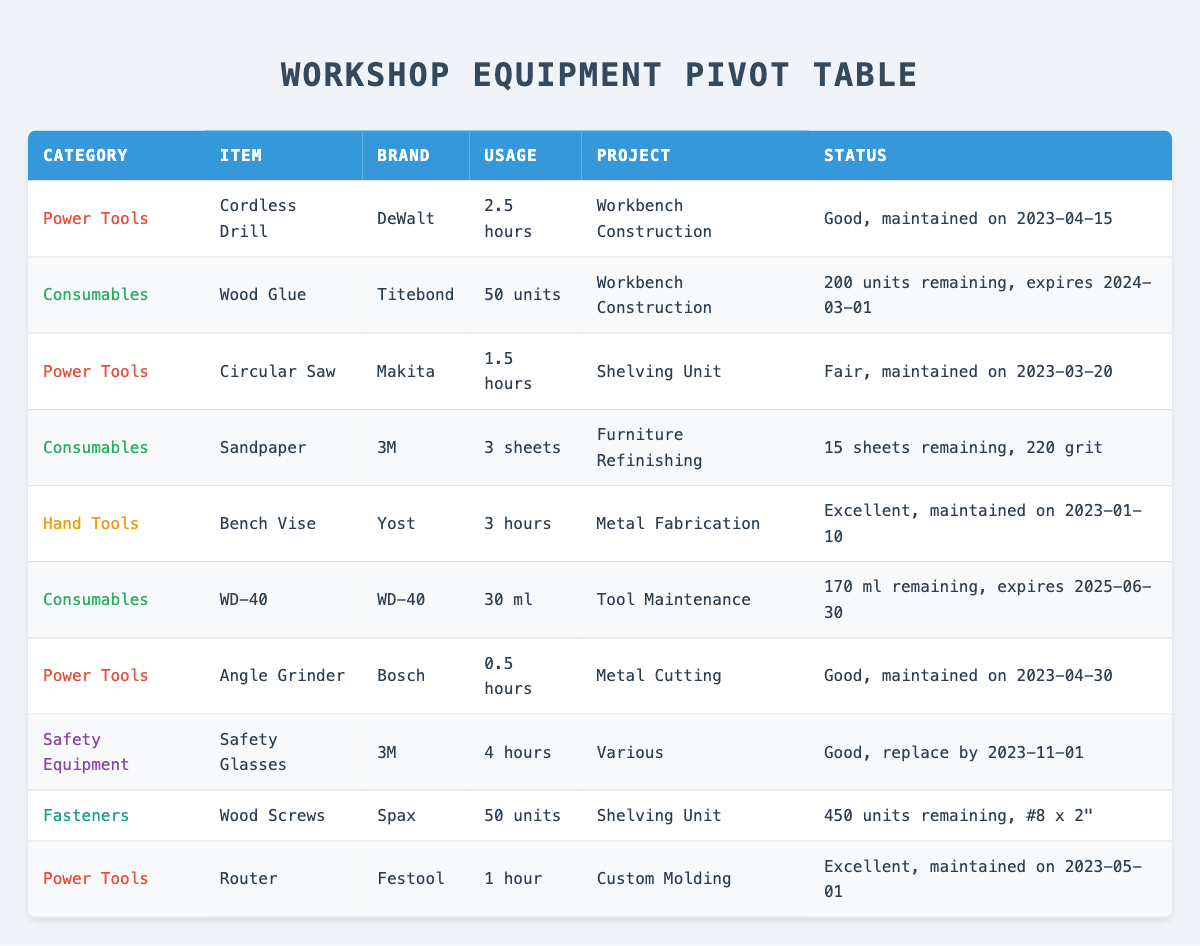What is the condition of the Circular Saw? The condition of the Circular Saw is mentioned in the table as "Fair". This is directly retrieved from the "Condition" column corresponding to the Circular Saw's row.
Answer: Fair How many units of Wood Glue are remaining in stock? The stock remaining for Wood Glue is listed in the table as 200 units. This is found in the "Stock Remaining" column for Wood Glue.
Answer: 200 units Which item has the highest usage duration, and what is that duration? The item with the highest usage duration listed is Safety Glasses with a duration of 4 hours. This is identified by checking the "Usage" column for the items and selecting the highest value.
Answer: Safety Glasses, 4 hours What is the total quantity of Wood Screws used across all projects? The total quantity of Wood Screws used is only indicated for one project, which is 50 units for the Shelving Unit. As there are no additional entries for Wood Screws in the table, the total usage is simply this amount.
Answer: 50 units Is the Cordless Drill due for maintenance soon? No, the Cordless Drill was last maintained on 2023-04-15. Given that there is no next upcoming maintenance date mentioned in the data, we can conclude it is not due for maintenance soon.
Answer: No How many power tools are in "Good" condition? There are three power tools listed in "Good" condition: Cordless Drill, Angle Grinder, and Safety Glasses. We can identify this by checking the "Condition" column for each power tool entry.
Answer: 3 What is the average usage duration of the power tools listed? The usage durations of the power tools are 2.5 hours (Cordless Drill), 1.5 hours (Circular Saw), 0.5 hours (Angle Grinder), and 1 hour (Router). Summing these yields 5.5 hours. Dividing by 4 power tools provides an average duration of 5.5 / 4 = 1.375 hours.
Answer: 1.375 hours What percentage of the total quantity of consumables used is WD-40? The total quantity of consumables used is 50 (Wood Glue) + 3 (Sandpaper) + 30 (WD-40) = 83 units used. The percentage for WD-40 is then calculated as (30 / 83) * 100 ≈ 36.14%.
Answer: 36.14% Are any items under "Fasteners" category used? Yes, there are items under the Fasteners category that are used, specifically 50 units of Wood Screws. This is clear from checking the "Category" column for Fasteners and confirming usage indicated in the "Quantity Used" column.
Answer: Yes 